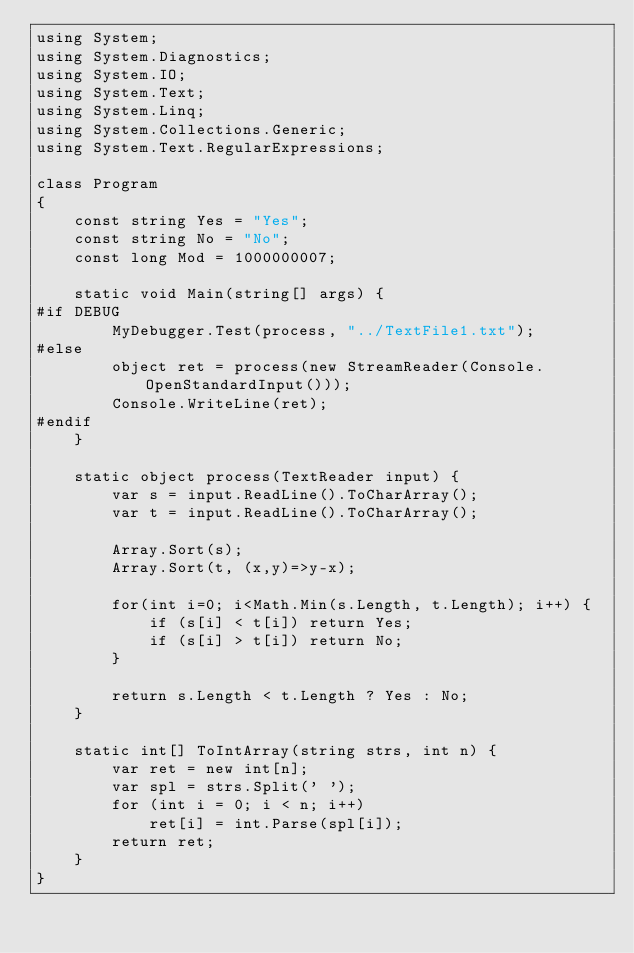Convert code to text. <code><loc_0><loc_0><loc_500><loc_500><_C#_>using System;
using System.Diagnostics;
using System.IO;
using System.Text;
using System.Linq;
using System.Collections.Generic;
using System.Text.RegularExpressions;

class Program
{
    const string Yes = "Yes";
    const string No = "No";
    const long Mod = 1000000007;

    static void Main(string[] args) {
#if DEBUG
        MyDebugger.Test(process, "../TextFile1.txt");
#else
        object ret = process(new StreamReader(Console.OpenStandardInput()));
        Console.WriteLine(ret);
#endif
    }

    static object process(TextReader input) {
        var s = input.ReadLine().ToCharArray();
        var t = input.ReadLine().ToCharArray();

        Array.Sort(s);
        Array.Sort(t, (x,y)=>y-x);

        for(int i=0; i<Math.Min(s.Length, t.Length); i++) {
            if (s[i] < t[i]) return Yes;
            if (s[i] > t[i]) return No;
        }

        return s.Length < t.Length ? Yes : No;
    }

    static int[] ToIntArray(string strs, int n) {
        var ret = new int[n];
        var spl = strs.Split(' ');
        for (int i = 0; i < n; i++)
            ret[i] = int.Parse(spl[i]);
        return ret;
    }
}
</code> 